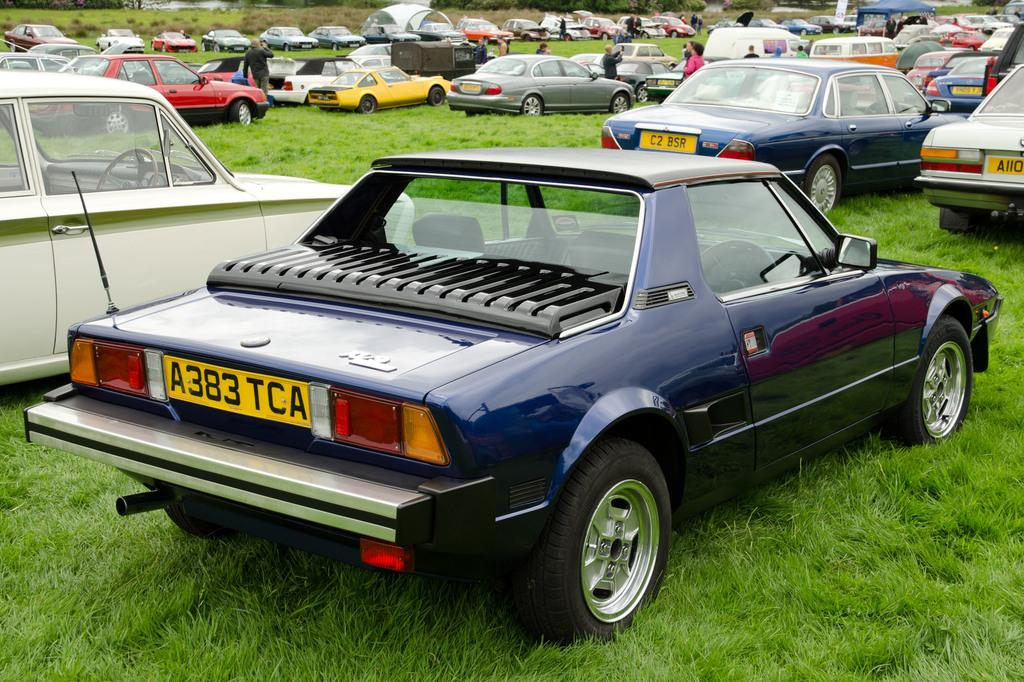What is the surface on which the cars are parked in the image? The cars are parked on the grass in the image. What can be seen on the cars to identify them individually? The cars have number plates in the image. How many people can be seen in the image? There are many people in the image. What type of kettle can be seen in the image? There is no kettle present in the image. What animal is interacting with the cars in the image? There are no animals interacting with the cars in the image. 